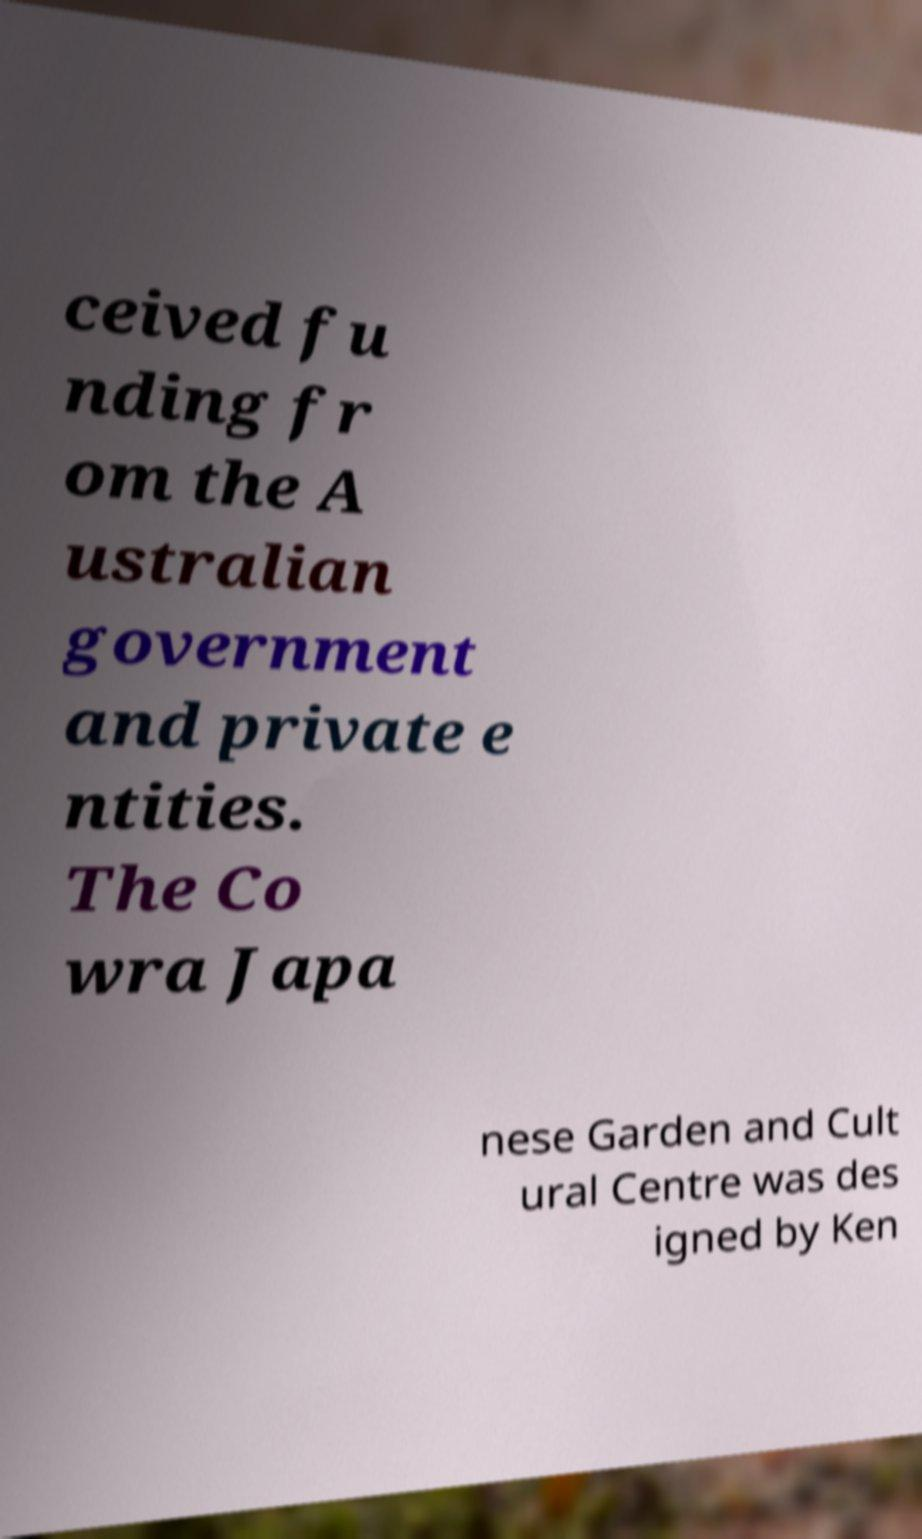I need the written content from this picture converted into text. Can you do that? ceived fu nding fr om the A ustralian government and private e ntities. The Co wra Japa nese Garden and Cult ural Centre was des igned by Ken 